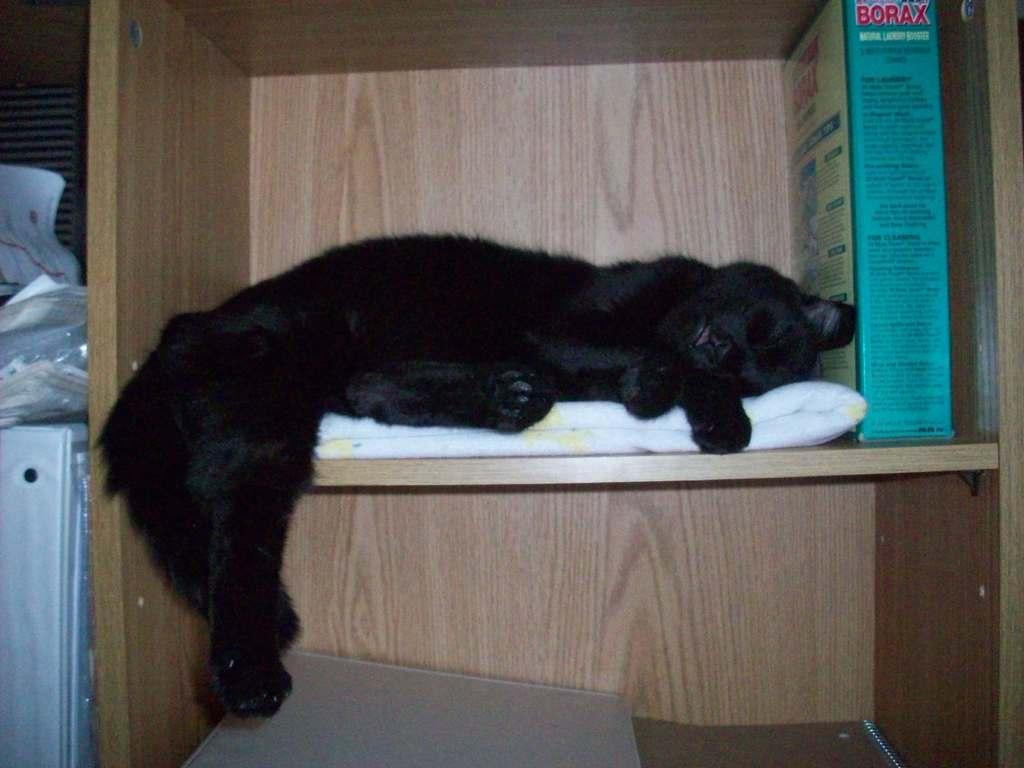Describe this image in one or two sentences. In this image we can see an animal. There are few objects in the cupboard. There are few objects in the image. 